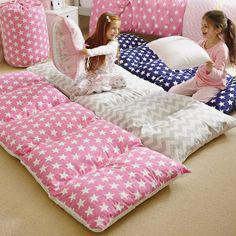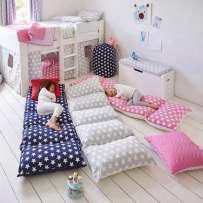The first image is the image on the left, the second image is the image on the right. For the images shown, is this caption "In the left image two kids are holding pillows" true? Answer yes or no. Yes. 